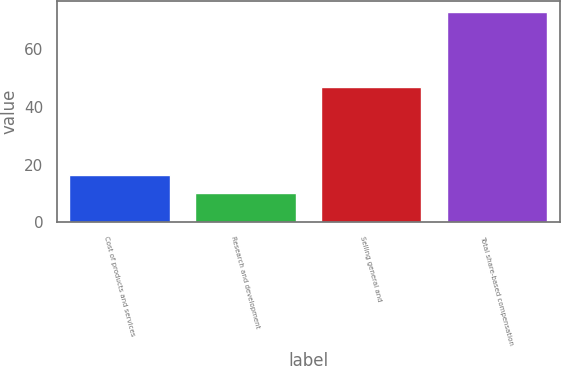Convert chart to OTSL. <chart><loc_0><loc_0><loc_500><loc_500><bar_chart><fcel>Cost of products and services<fcel>Research and development<fcel>Selling general and<fcel>Total share-based compensation<nl><fcel>16.3<fcel>10<fcel>47<fcel>73<nl></chart> 